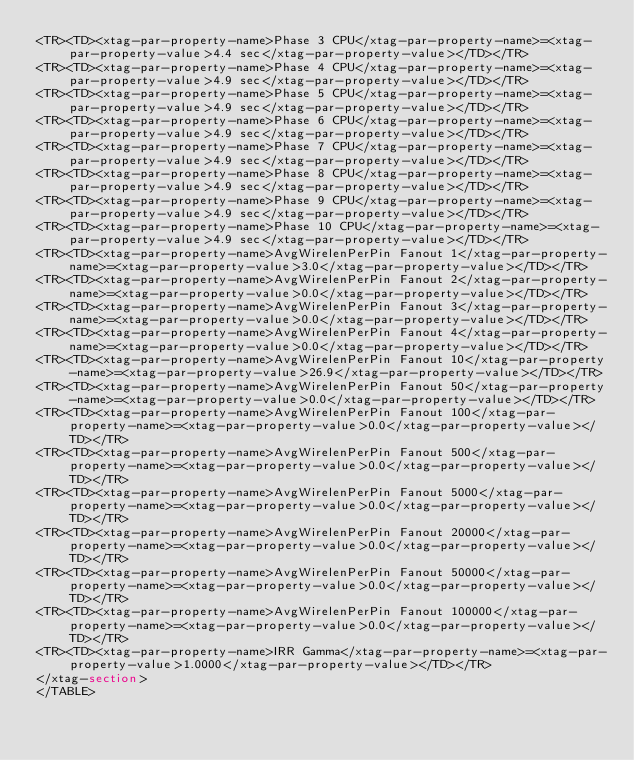<code> <loc_0><loc_0><loc_500><loc_500><_HTML_><TR><TD><xtag-par-property-name>Phase 3 CPU</xtag-par-property-name>=<xtag-par-property-value>4.4 sec</xtag-par-property-value></TD></TR>
<TR><TD><xtag-par-property-name>Phase 4 CPU</xtag-par-property-name>=<xtag-par-property-value>4.9 sec</xtag-par-property-value></TD></TR>
<TR><TD><xtag-par-property-name>Phase 5 CPU</xtag-par-property-name>=<xtag-par-property-value>4.9 sec</xtag-par-property-value></TD></TR>
<TR><TD><xtag-par-property-name>Phase 6 CPU</xtag-par-property-name>=<xtag-par-property-value>4.9 sec</xtag-par-property-value></TD></TR>
<TR><TD><xtag-par-property-name>Phase 7 CPU</xtag-par-property-name>=<xtag-par-property-value>4.9 sec</xtag-par-property-value></TD></TR>
<TR><TD><xtag-par-property-name>Phase 8 CPU</xtag-par-property-name>=<xtag-par-property-value>4.9 sec</xtag-par-property-value></TD></TR>
<TR><TD><xtag-par-property-name>Phase 9 CPU</xtag-par-property-name>=<xtag-par-property-value>4.9 sec</xtag-par-property-value></TD></TR>
<TR><TD><xtag-par-property-name>Phase 10 CPU</xtag-par-property-name>=<xtag-par-property-value>4.9 sec</xtag-par-property-value></TD></TR>
<TR><TD><xtag-par-property-name>AvgWirelenPerPin Fanout 1</xtag-par-property-name>=<xtag-par-property-value>3.0</xtag-par-property-value></TD></TR>
<TR><TD><xtag-par-property-name>AvgWirelenPerPin Fanout 2</xtag-par-property-name>=<xtag-par-property-value>0.0</xtag-par-property-value></TD></TR>
<TR><TD><xtag-par-property-name>AvgWirelenPerPin Fanout 3</xtag-par-property-name>=<xtag-par-property-value>0.0</xtag-par-property-value></TD></TR>
<TR><TD><xtag-par-property-name>AvgWirelenPerPin Fanout 4</xtag-par-property-name>=<xtag-par-property-value>0.0</xtag-par-property-value></TD></TR>
<TR><TD><xtag-par-property-name>AvgWirelenPerPin Fanout 10</xtag-par-property-name>=<xtag-par-property-value>26.9</xtag-par-property-value></TD></TR>
<TR><TD><xtag-par-property-name>AvgWirelenPerPin Fanout 50</xtag-par-property-name>=<xtag-par-property-value>0.0</xtag-par-property-value></TD></TR>
<TR><TD><xtag-par-property-name>AvgWirelenPerPin Fanout 100</xtag-par-property-name>=<xtag-par-property-value>0.0</xtag-par-property-value></TD></TR>
<TR><TD><xtag-par-property-name>AvgWirelenPerPin Fanout 500</xtag-par-property-name>=<xtag-par-property-value>0.0</xtag-par-property-value></TD></TR>
<TR><TD><xtag-par-property-name>AvgWirelenPerPin Fanout 5000</xtag-par-property-name>=<xtag-par-property-value>0.0</xtag-par-property-value></TD></TR>
<TR><TD><xtag-par-property-name>AvgWirelenPerPin Fanout 20000</xtag-par-property-name>=<xtag-par-property-value>0.0</xtag-par-property-value></TD></TR>
<TR><TD><xtag-par-property-name>AvgWirelenPerPin Fanout 50000</xtag-par-property-name>=<xtag-par-property-value>0.0</xtag-par-property-value></TD></TR>
<TR><TD><xtag-par-property-name>AvgWirelenPerPin Fanout 100000</xtag-par-property-name>=<xtag-par-property-value>0.0</xtag-par-property-value></TD></TR>
<TR><TD><xtag-par-property-name>IRR Gamma</xtag-par-property-name>=<xtag-par-property-value>1.0000</xtag-par-property-value></TD></TR>
</xtag-section>
</TABLE>
</code> 